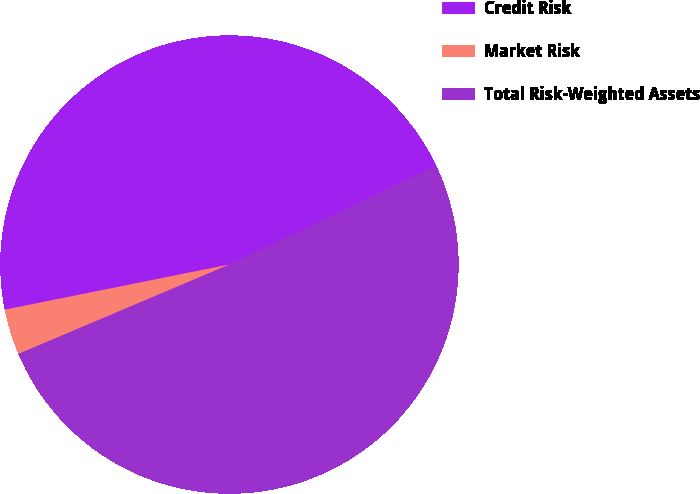Convert chart. <chart><loc_0><loc_0><loc_500><loc_500><pie_chart><fcel>Credit Risk<fcel>Market Risk<fcel>Total Risk-Weighted Assets<nl><fcel>46.08%<fcel>3.22%<fcel>50.69%<nl></chart> 